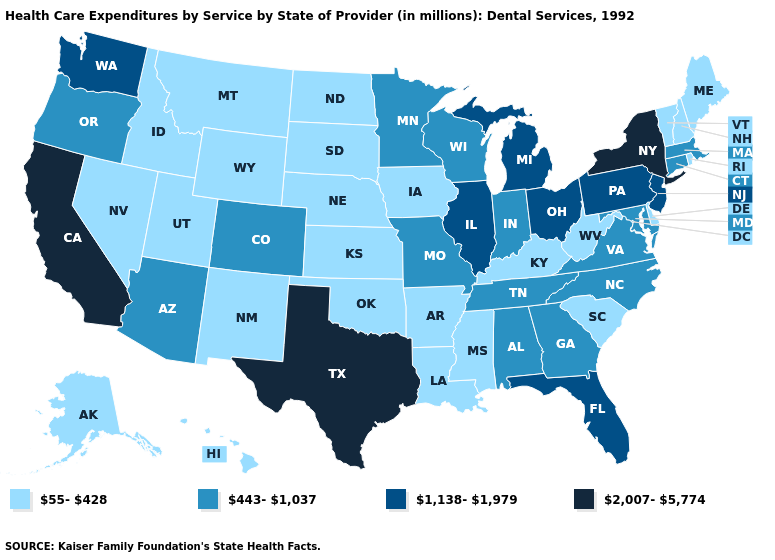What is the value of Colorado?
Quick response, please. 443-1,037. What is the value of Pennsylvania?
Answer briefly. 1,138-1,979. How many symbols are there in the legend?
Short answer required. 4. Does Texas have the highest value in the USA?
Write a very short answer. Yes. Does North Carolina have the lowest value in the South?
Answer briefly. No. What is the value of Nebraska?
Concise answer only. 55-428. Does Illinois have the same value as Oklahoma?
Short answer required. No. Name the states that have a value in the range 55-428?
Be succinct. Alaska, Arkansas, Delaware, Hawaii, Idaho, Iowa, Kansas, Kentucky, Louisiana, Maine, Mississippi, Montana, Nebraska, Nevada, New Hampshire, New Mexico, North Dakota, Oklahoma, Rhode Island, South Carolina, South Dakota, Utah, Vermont, West Virginia, Wyoming. What is the value of North Dakota?
Concise answer only. 55-428. Is the legend a continuous bar?
Be succinct. No. What is the lowest value in the USA?
Give a very brief answer. 55-428. What is the highest value in the Northeast ?
Give a very brief answer. 2,007-5,774. Does Minnesota have the lowest value in the USA?
Quick response, please. No. Which states have the highest value in the USA?
Be succinct. California, New York, Texas. What is the value of California?
Short answer required. 2,007-5,774. 